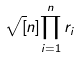Convert formula to latex. <formula><loc_0><loc_0><loc_500><loc_500>\sqrt { [ } n ] { \prod _ { i = 1 } ^ { n } r _ { i } }</formula> 